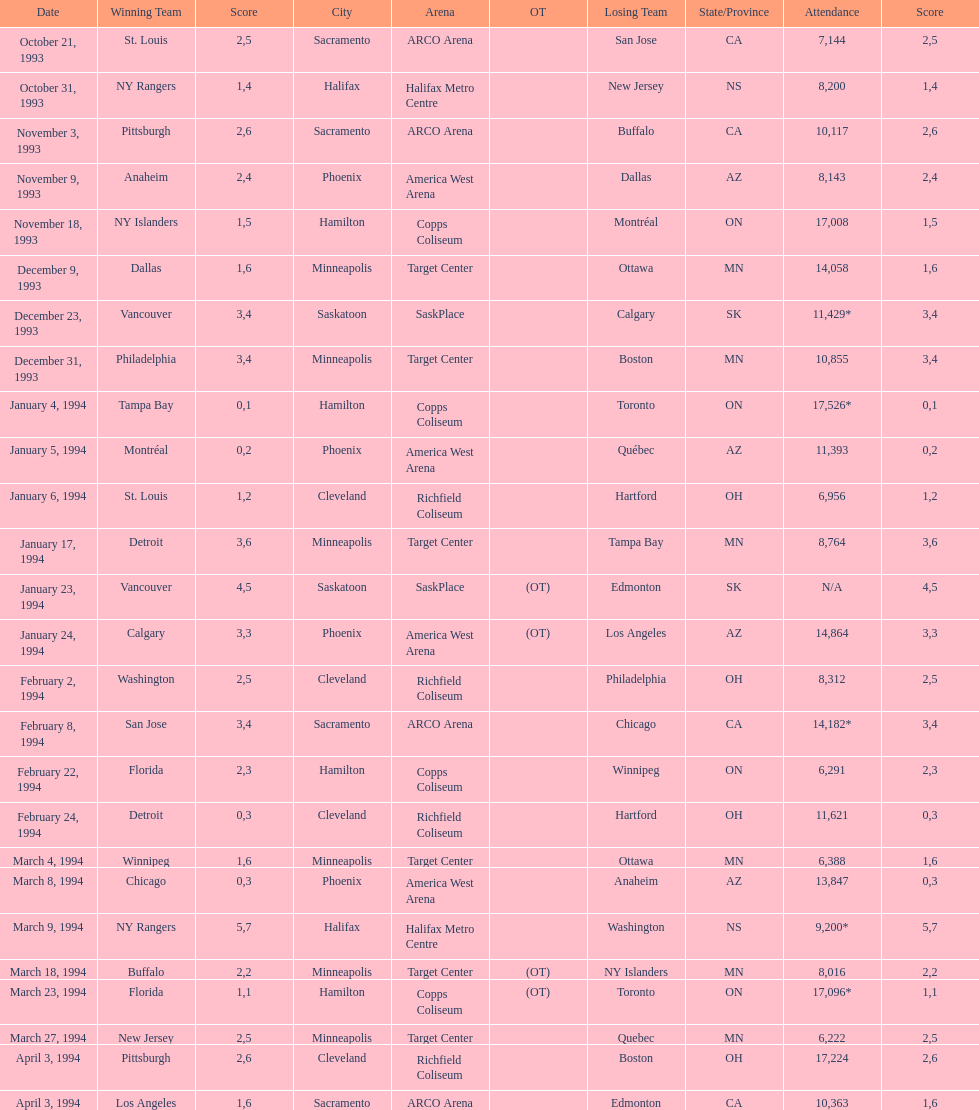Who won the game the day before the january 5, 1994 game? Tampa Bay. 